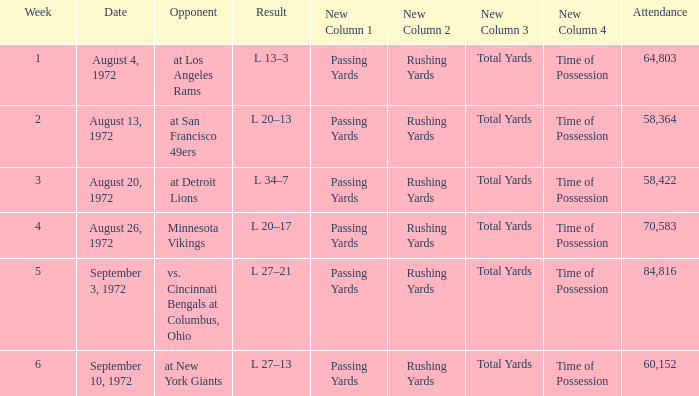What is the date of week 4? August 26, 1972. 